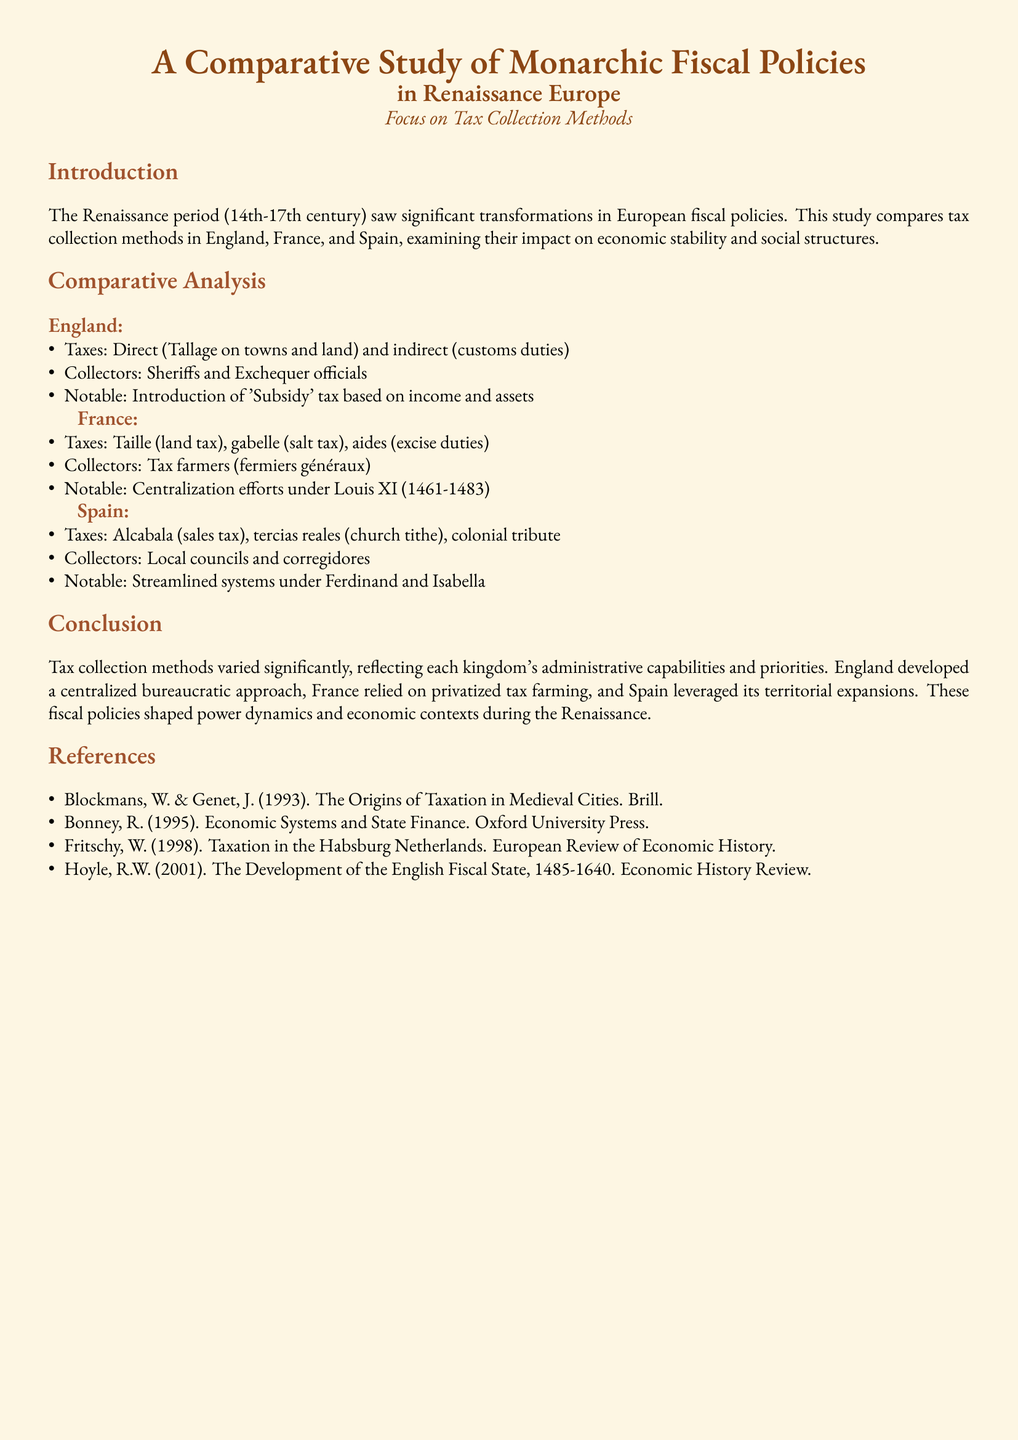What were the direct taxes in England? The document lists direct taxes in England as Tallage on towns and land.
Answer: Tallage on towns and land Who were the collectors of taxes in France? The document specifies that tax collectors in France were known as tax farmers or fermiers généraux.
Answer: Tax farmers (fermiers généraux) What tax was introduced in England based on income and assets? The study mentions the introduction of the 'Subsidy' tax in England.
Answer: 'Subsidy' tax Which tax is associated with land in France? The document states that Taille refers to the land tax in France.
Answer: Taille Who streamlined the tax systems in Spain? The document notes that tax systems were streamlined under Ferdinand and Isabella.
Answer: Ferdinand and Isabella What was a notable feature of tax collection in Spain? The summary mentions colonial tribute as a unique feature of Spain's tax collection.
Answer: Colonial tribute What type of analysis is conducted in the study? The document clarifies that the study performs a comparative analysis of fiscal policies.
Answer: Comparative analysis What is the time period focused on in the study? The introduction emphasizes the Renaissance period from the 14th to 17th century.
Answer: 14th-17th century 